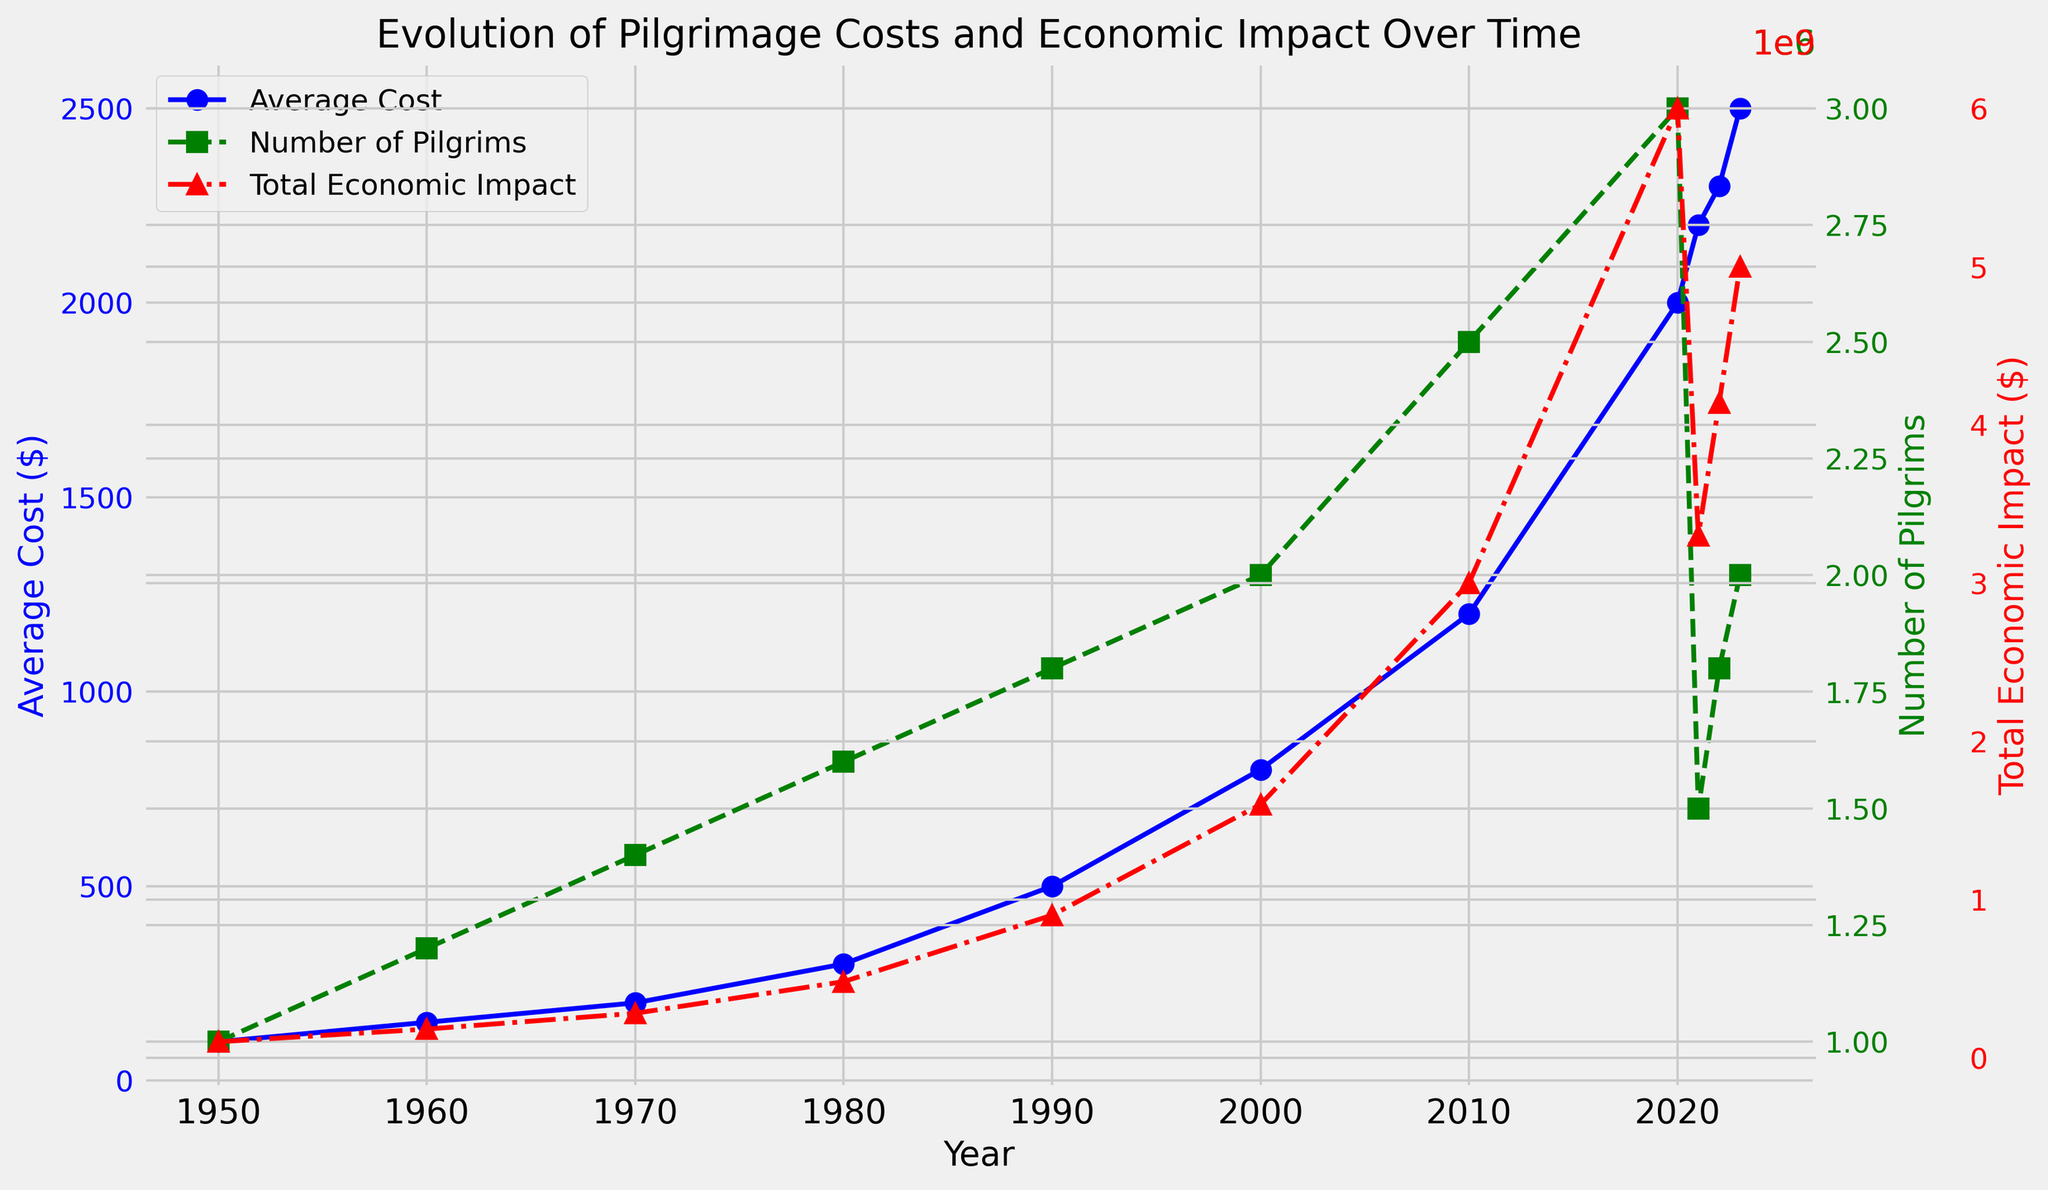What was the Average Cost in the year 2000? By looking at the blue line corresponding to the Average Cost in the year 2000, we can identify the data point.
Answer: 800 In which year did the Number of Pilgrims peak? By observing the green line which represents the Number of Pilgrims, we can see it peaks in the year 2020.
Answer: 2020 Compare the Total Economic Impact between 2020 and 2021. Which year had a higher impact? The red line representing Total Economic Impact shows higher values in the year 2020 compared to 2021.
Answer: 2020 What is the difference between the Average Cost in 1980 and 2023? The Average Cost in 1980 is indicated by the blue line and is $300, while in 2023 it is $2500. The difference is $2500 - $300.
Answer: $2200 Did the Number of Pilgrims ever decrease from one year to the next in the given data? By examining the trend in the green line, we observe a decrease from 2020 to 2021.
Answer: Yes What was the Total Economic Impact in 1990? The red line corresponding to the Total Economic Impact in the year 1990 indicates the value.
Answer: $900,000,000 Is there a year where both the Average Cost and Number of Pilgrims increased? To answer, observe the blue and green lines. Both increased in the years until 2020, but not after.
Answer: Until 2020 How does the trend of the Average Cost compare to the trend of the Number of Pilgrims in the later years (2020-2023)? Analyze the trends: the blue line (Average Cost) continues to increase while the green line (Number of Pilgrims) shows a decline and slight recovery.
Answer: Diverging trends What was the increase in Total Economic Impact from 1950 to 2023? The Total Economic Impact in 1950 was $100,000,000 and in 2023, it was $5,000,000,000. The increase is $5,000,000,000 - $100,000,000.
Answer: $4,900,000,000 Which line represents the highest value in the year 2023? By comparing the highest points of the blue, green, and red lines in 2023, we see the red line (Total Economic Impact) has the highest value.
Answer: Total Economic Impact 